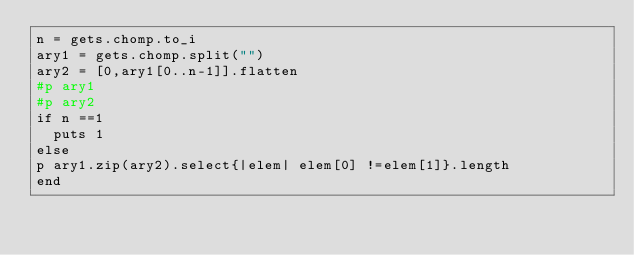Convert code to text. <code><loc_0><loc_0><loc_500><loc_500><_Ruby_>n = gets.chomp.to_i
ary1 = gets.chomp.split("")
ary2 = [0,ary1[0..n-1]].flatten
#p ary1
#p ary2
if n ==1
  puts 1
else
p ary1.zip(ary2).select{|elem| elem[0] !=elem[1]}.length
end</code> 